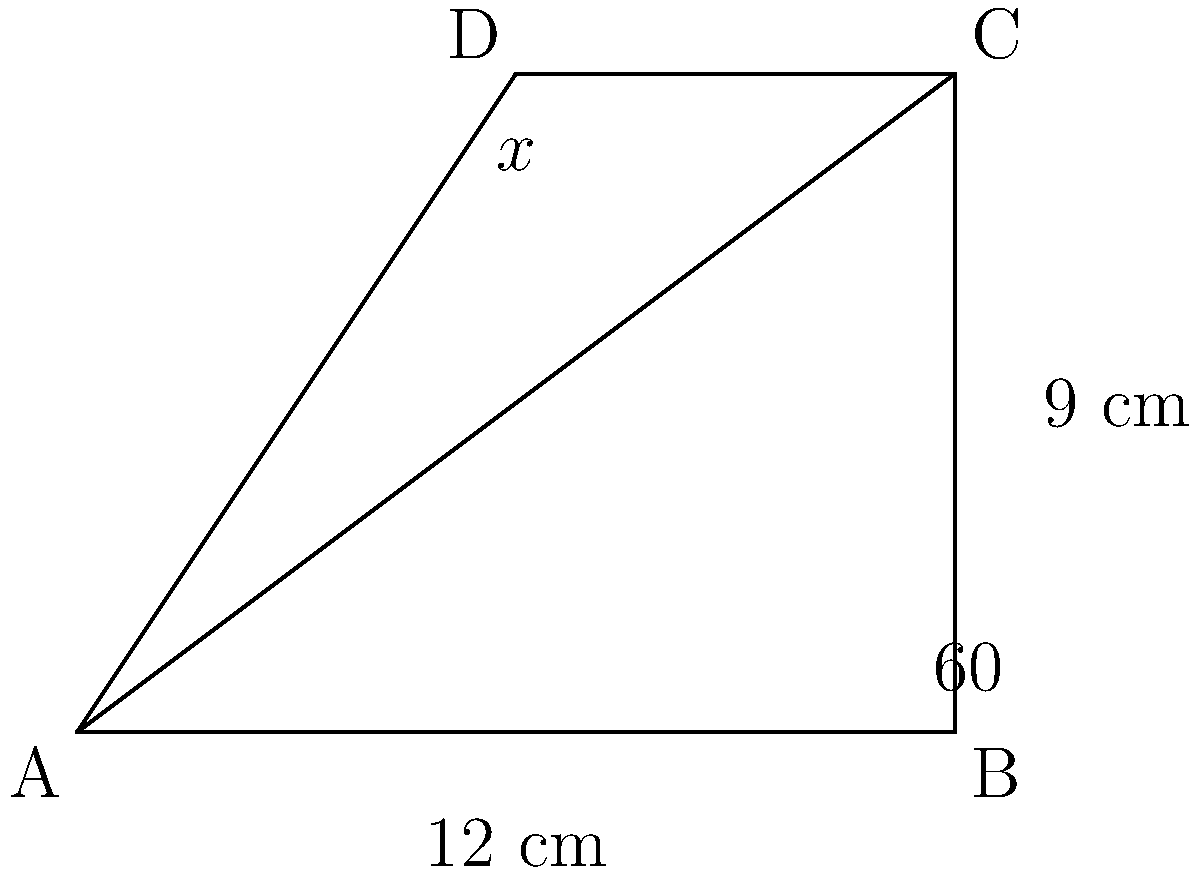In a state-of-the-art robotic arm used for minimally invasive surgery, the main joint forms a triangle ABC as shown in the diagram. If angle BAC is 60°, BC is 9 cm, and AB is 12 cm, what is the measure of angle ACD (represented by x°) when the arm is in this position? Let's approach this step-by-step:

1) First, we need to find angle ABC. We can do this using the law of cosines:

   $$BC^2 = AB^2 + AC^2 - 2(AB)(AC)\cos(BAC)$$

2) Substituting the known values:

   $$9^2 = 12^2 + AC^2 - 2(12)(AC)\cos(60°)$$

3) Simplify:

   $$81 = 144 + AC^2 - 12AC(\frac{1}{2})$$

4) Solve for AC:

   $$AC^2 - 6AC - 63 = 0$$
   $$(AC - 9)(AC + 3) = 0$$
   $$AC = 9$$ (we discard the negative solution)

5) Now we know all sides of the triangle. We can find angle ABC using the law of sines:

   $$\frac{\sin(ABC)}{9} = \frac{\sin(60°)}{12}$$

6) Solve for ABC:

   $$ABC = \arcsin(\frac{9\sin(60°)}{12}) \approx 41.8°$$

7) The sum of angles in a triangle is 180°, so:

   $$BCA = 180° - 60° - 41.8° = 78.2°$$

8) In the triangle ACD, we now know two angles:
   - CAD = 60° (given)
   - ACD = x° (what we're solving for)
   - ADC = 78.2° (equal to BCA, as they're alternate angles)

9) The sum of angles in a triangle is 180°, so:

   $$60° + x° + 78.2° = 180°$$
   $$x° = 41.8°$$

Therefore, angle ACD (x°) measures 41.8°.
Answer: 41.8° 